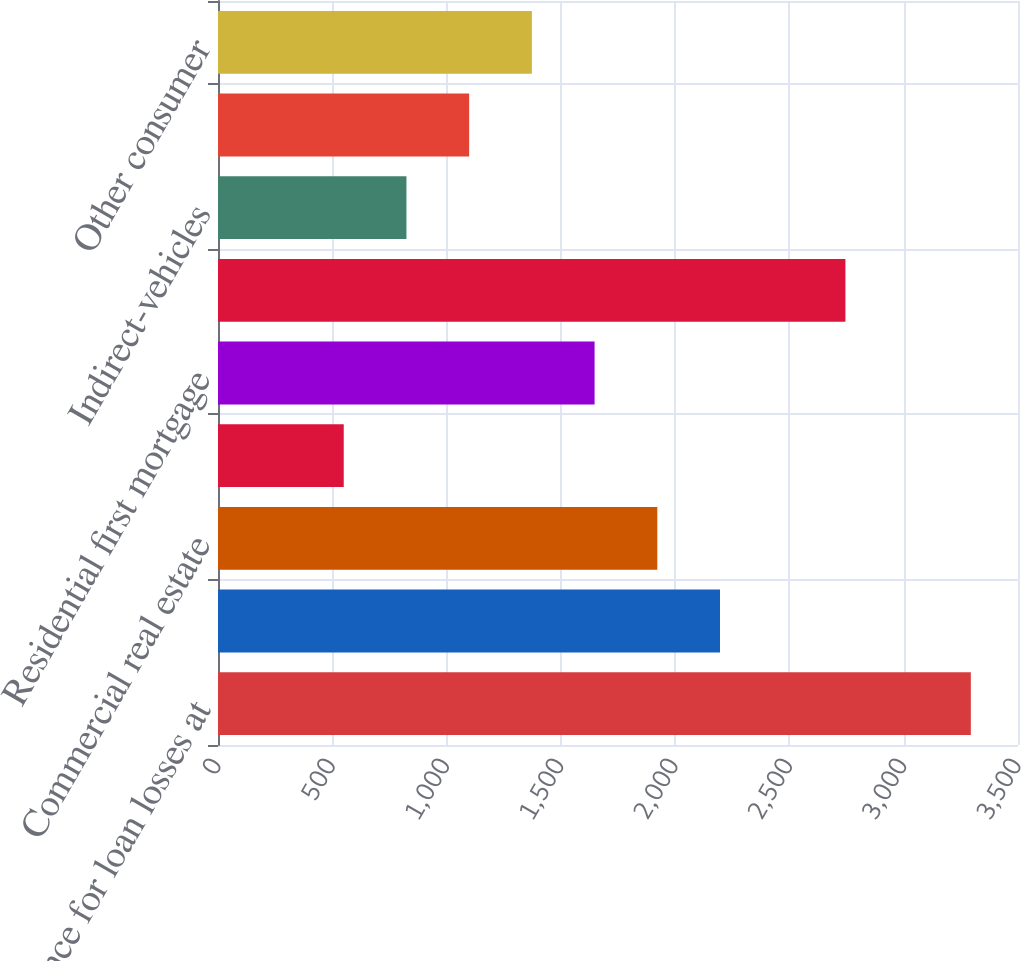Convert chart to OTSL. <chart><loc_0><loc_0><loc_500><loc_500><bar_chart><fcel>Allowance for loan losses at<fcel>Commercial and industrial<fcel>Commercial real estate<fcel>Commercial investor real<fcel>Residential first mortgage<fcel>Home equity<fcel>Indirect-vehicles<fcel>Consumer credit card<fcel>Other consumer<nl><fcel>3293.69<fcel>2196.25<fcel>1921.89<fcel>550.09<fcel>1647.53<fcel>2744.97<fcel>824.45<fcel>1098.81<fcel>1373.17<nl></chart> 